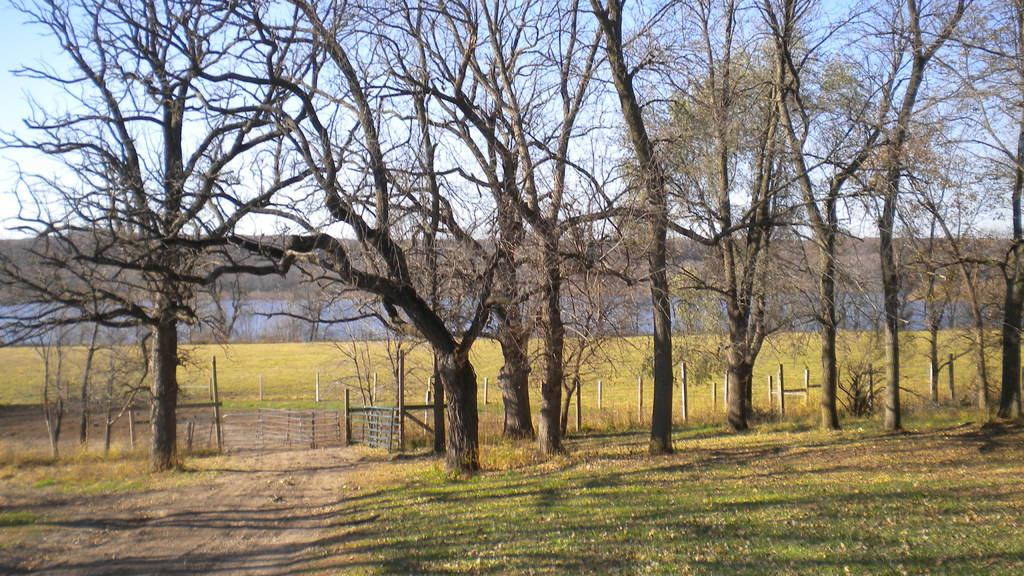What type of vegetation can be seen in the image? There are dried trees in the image. What is located beside the dried trees? There is a fence beside the dried trees. What can be observed about the ground in the image? The ground appears to have greenery. What type of minister is depicted in the image? There is no minister present in the image; it features dried trees, a fence, and greenery on the ground. 